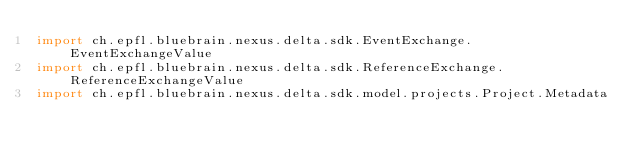Convert code to text. <code><loc_0><loc_0><loc_500><loc_500><_Scala_>import ch.epfl.bluebrain.nexus.delta.sdk.EventExchange.EventExchangeValue
import ch.epfl.bluebrain.nexus.delta.sdk.ReferenceExchange.ReferenceExchangeValue
import ch.epfl.bluebrain.nexus.delta.sdk.model.projects.Project.Metadata</code> 